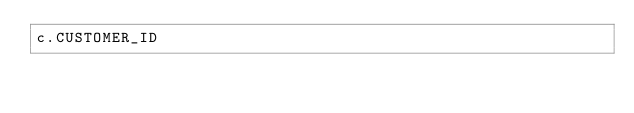<code> <loc_0><loc_0><loc_500><loc_500><_SQL_>c.CUSTOMER_ID</code> 